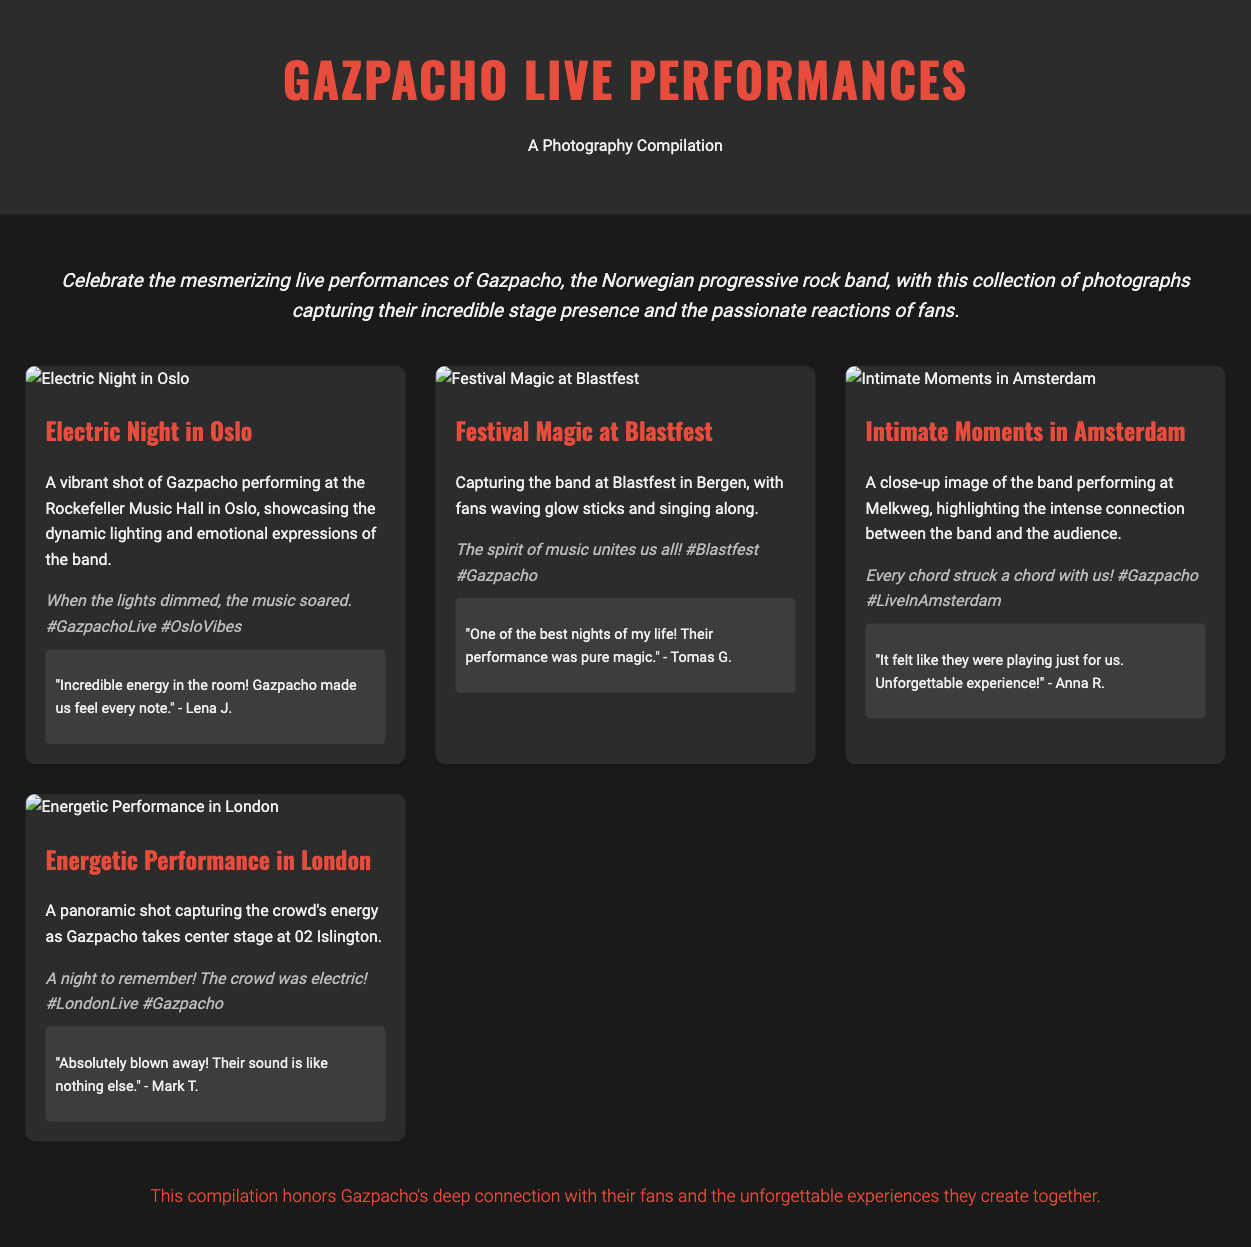What is the title of the document? The title of the document is presented prominently in the header section.
Answer: Gazpacho Live Performances: A Photography Compilation How many photo items are there in the document? The document contains a grid of four photo items showcasing the band's performances.
Answer: Four What is the caption for the photo titled "Electric Night in Oslo"? Each photo item includes a caption, showing the specific sentiment related to that performance.
Answer: When the lights dimmed, the music soared. #GazpachoLive #OsloVibes Who is the fan that commented on the "Festival Magic at Blastfest" photo? Fan reactions are included under each photo item, listing the name of the fan who provided feedback.
Answer: Tomas G What venue is mentioned for the performance in Amsterdam? The photo titled "Intimate Moments in Amsterdam" indicates the venue where the performance took place.
Answer: Melkweg Which city is referenced in the title of the last photo item? The title of the photo "Energetic Performance in London" specifies the city where this performance occurred.
Answer: London What color is the header background? The style section specifies the color used for the header's background.
Answer: Dark gray What emotion does the intro paragraph convey about Gazpacho's performances? The intro paragraph reflects the overall feeling about Gazpacho's live performances.
Answer: Mesmerizing 